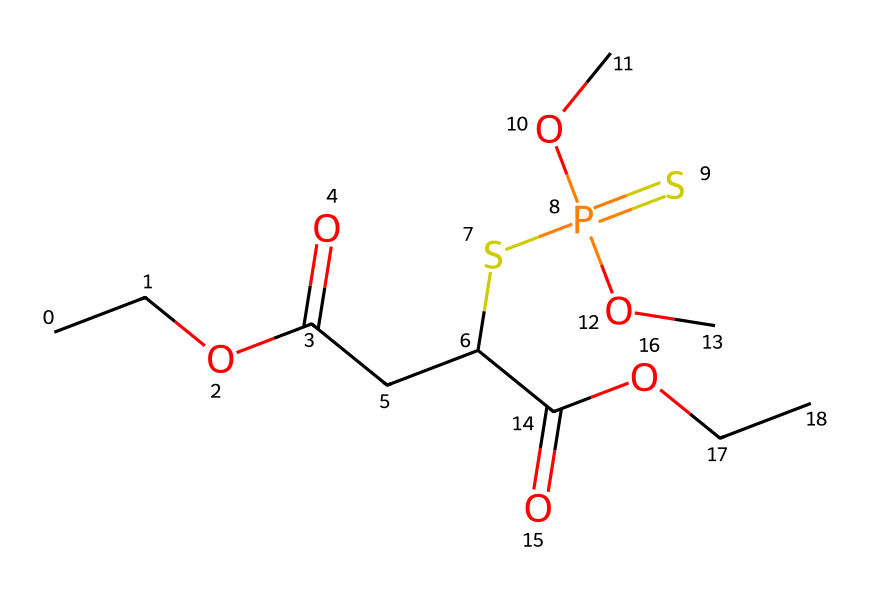What is the molecular formula of this compound? To determine the molecular formula, we need to count the number of each type of atom in the SMILES representation. In this case, we analyze the SMILES, which includes elements like carbon (C), hydrogen (H), oxygen (O), and phosphorus (P). Counting gives us C12H19O6P, which is the formula.
Answer: C12H19O6P How many carbon atoms are present in this structure? By inspecting the SMILES representation, we identify each carbon atom denoted by "C". Counting all occurrences leads to a total of 12 carbon atoms in the structure.
Answer: 12 Which functional group is present in the molecule? Looking at the SMILES, we can identify several functional groups, but one prominent group is the phosphonate group (–P(=O)(O)O). This indicates that the compound belongs to organophosphates.
Answer: phosphonate Does this molecule contain sulfur? In the SMILES representation, we spot the presence of sulfur represented by "S". Therefore, we can confirm that there is at least one sulfur atom included in this chemical structure.
Answer: yes What is the main concern regarding organophosphate pesticides? The primary concern relates to their potential toxicity to humans and the environment. This toxicity is linked to the chemical's ability to inhibit enzymes like acetylcholinesterase, which is critical for nerve function.
Answer: toxicity Is this a water-soluble compound? Organophosphates, including this one, usually have polar functional groups allowing for solubility in water. The presence of multiple oxygen atoms contributes to this solubility, so it's reasonable to conclude that it is indeed water-soluble.
Answer: yes How many oxygen atoms are there in this compound? The SMILES shows multiple occurrences of the letter "O", which represents oxygen. Counting these occurrences provides us with a total of 6 oxygen atoms in the structure.
Answer: 6 